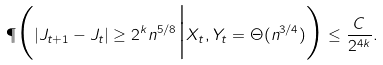<formula> <loc_0><loc_0><loc_500><loc_500>\P \Big ( | J _ { t + 1 } - J _ { t } | \geq 2 ^ { k } n ^ { 5 / 8 } \Big | X _ { t } , Y _ { t } = \Theta ( n ^ { 3 / 4 } ) \Big ) \leq \frac { C } { 2 ^ { 4 k } } .</formula> 